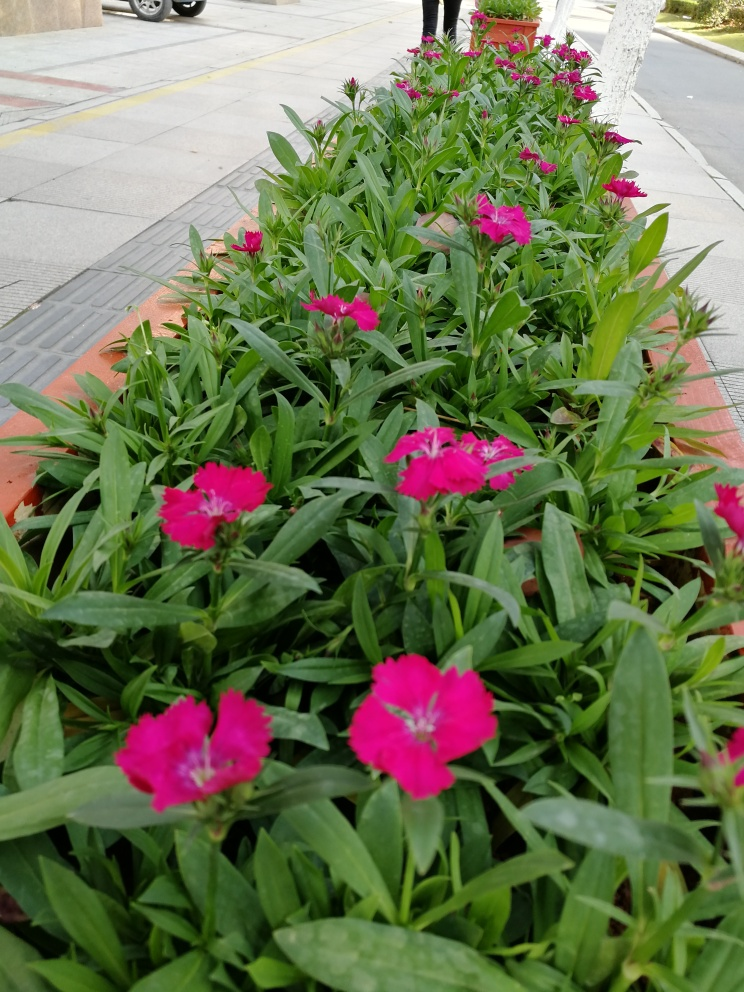What kind of flowers are these? These appear to be pink Dianthus flowers, known for their vibrant colors and jagged petal tips. 